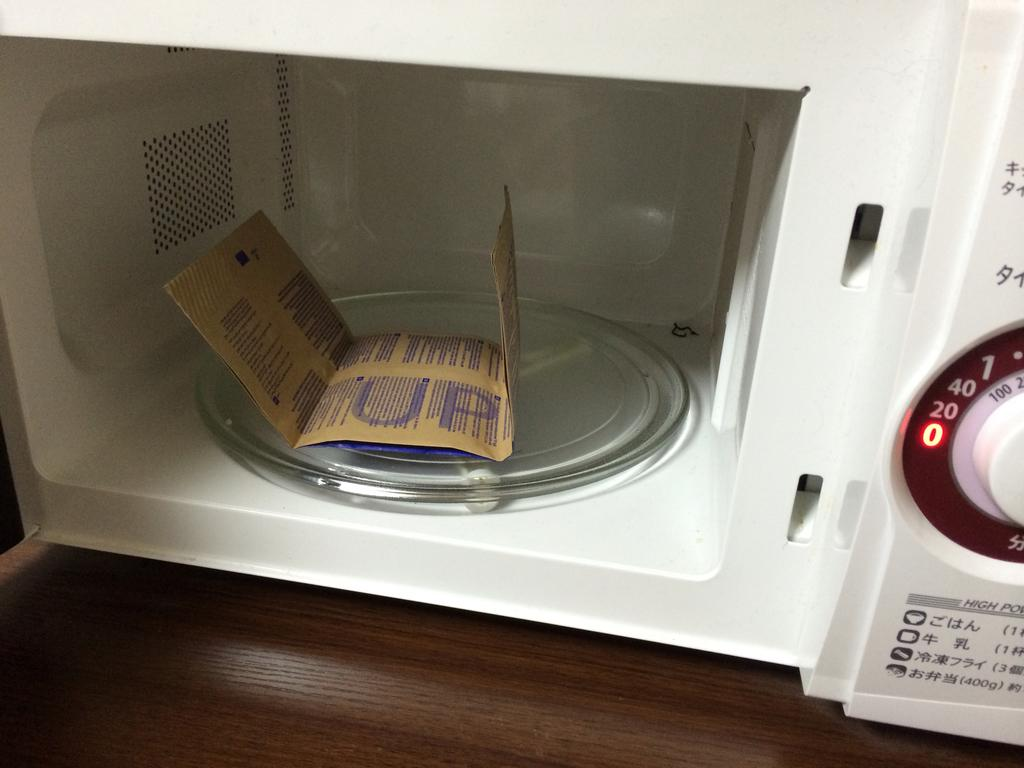<image>
Offer a succinct explanation of the picture presented. some popcorn with the word up on it in a microwave 